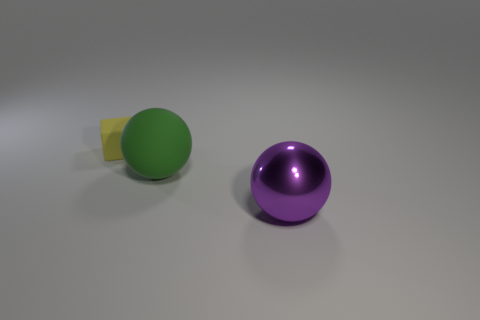What number of other things are the same size as the purple ball?
Your answer should be very brief. 1. What is the material of the thing that is in front of the tiny yellow thing and behind the purple sphere?
Provide a succinct answer. Rubber. There is a big purple thing that is the same shape as the large green object; what is its material?
Give a very brief answer. Metal. How many large shiny objects are behind the small rubber object to the left of the object that is in front of the rubber sphere?
Ensure brevity in your answer.  0. Are there any other things that have the same color as the large metal thing?
Provide a succinct answer. No. How many objects are left of the large shiny ball and to the right of the tiny yellow matte cube?
Provide a succinct answer. 1. There is a sphere that is behind the purple sphere; is it the same size as the thing that is behind the big rubber sphere?
Provide a short and direct response. No. What number of objects are either objects behind the purple ball or tiny yellow rubber cubes?
Offer a terse response. 2. There is a big thing in front of the matte sphere; what material is it?
Provide a short and direct response. Metal. What is the green object made of?
Keep it short and to the point. Rubber. 